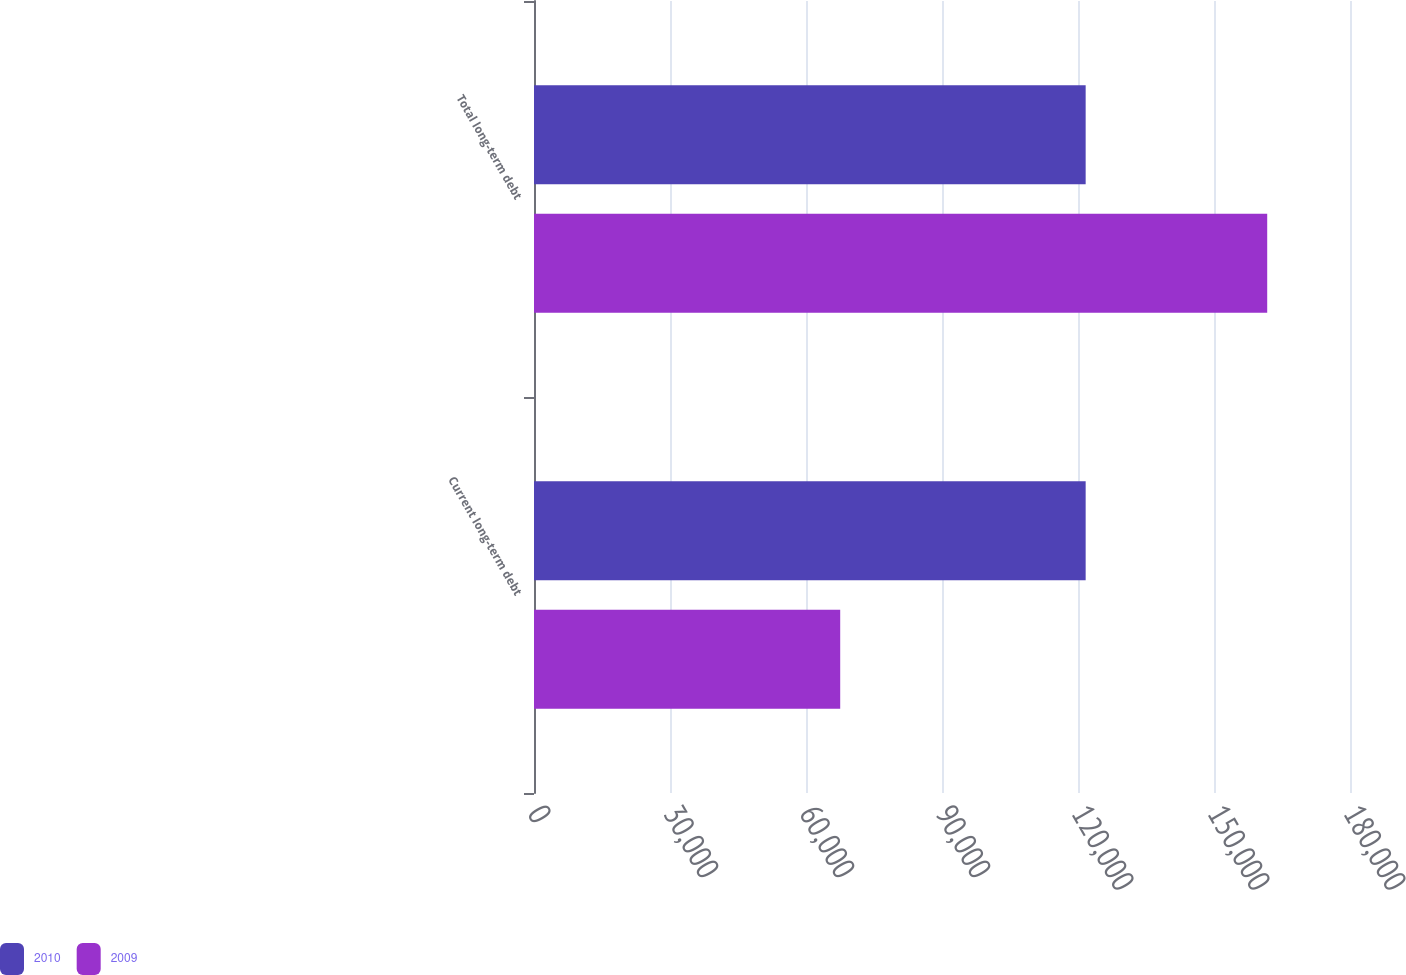Convert chart. <chart><loc_0><loc_0><loc_500><loc_500><stacked_bar_chart><ecel><fcel>Current long-term debt<fcel>Total long-term debt<nl><fcel>2010<fcel>121689<fcel>121689<nl><fcel>2009<fcel>67545<fcel>161736<nl></chart> 